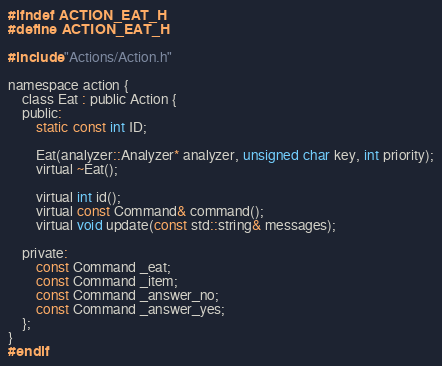Convert code to text. <code><loc_0><loc_0><loc_500><loc_500><_C_>#ifndef ACTION_EAT_H
#define ACTION_EAT_H

#include "Actions/Action.h"

namespace action {
	class Eat : public Action {
	public:
		static const int ID;

		Eat(analyzer::Analyzer* analyzer, unsigned char key, int priority);
		virtual ~Eat();

		virtual int id();
		virtual const Command& command();
		virtual void update(const std::string& messages);

	private:
		const Command _eat;
		const Command _item;
		const Command _answer_no;
		const Command _answer_yes;
	};
}
#endif
</code> 